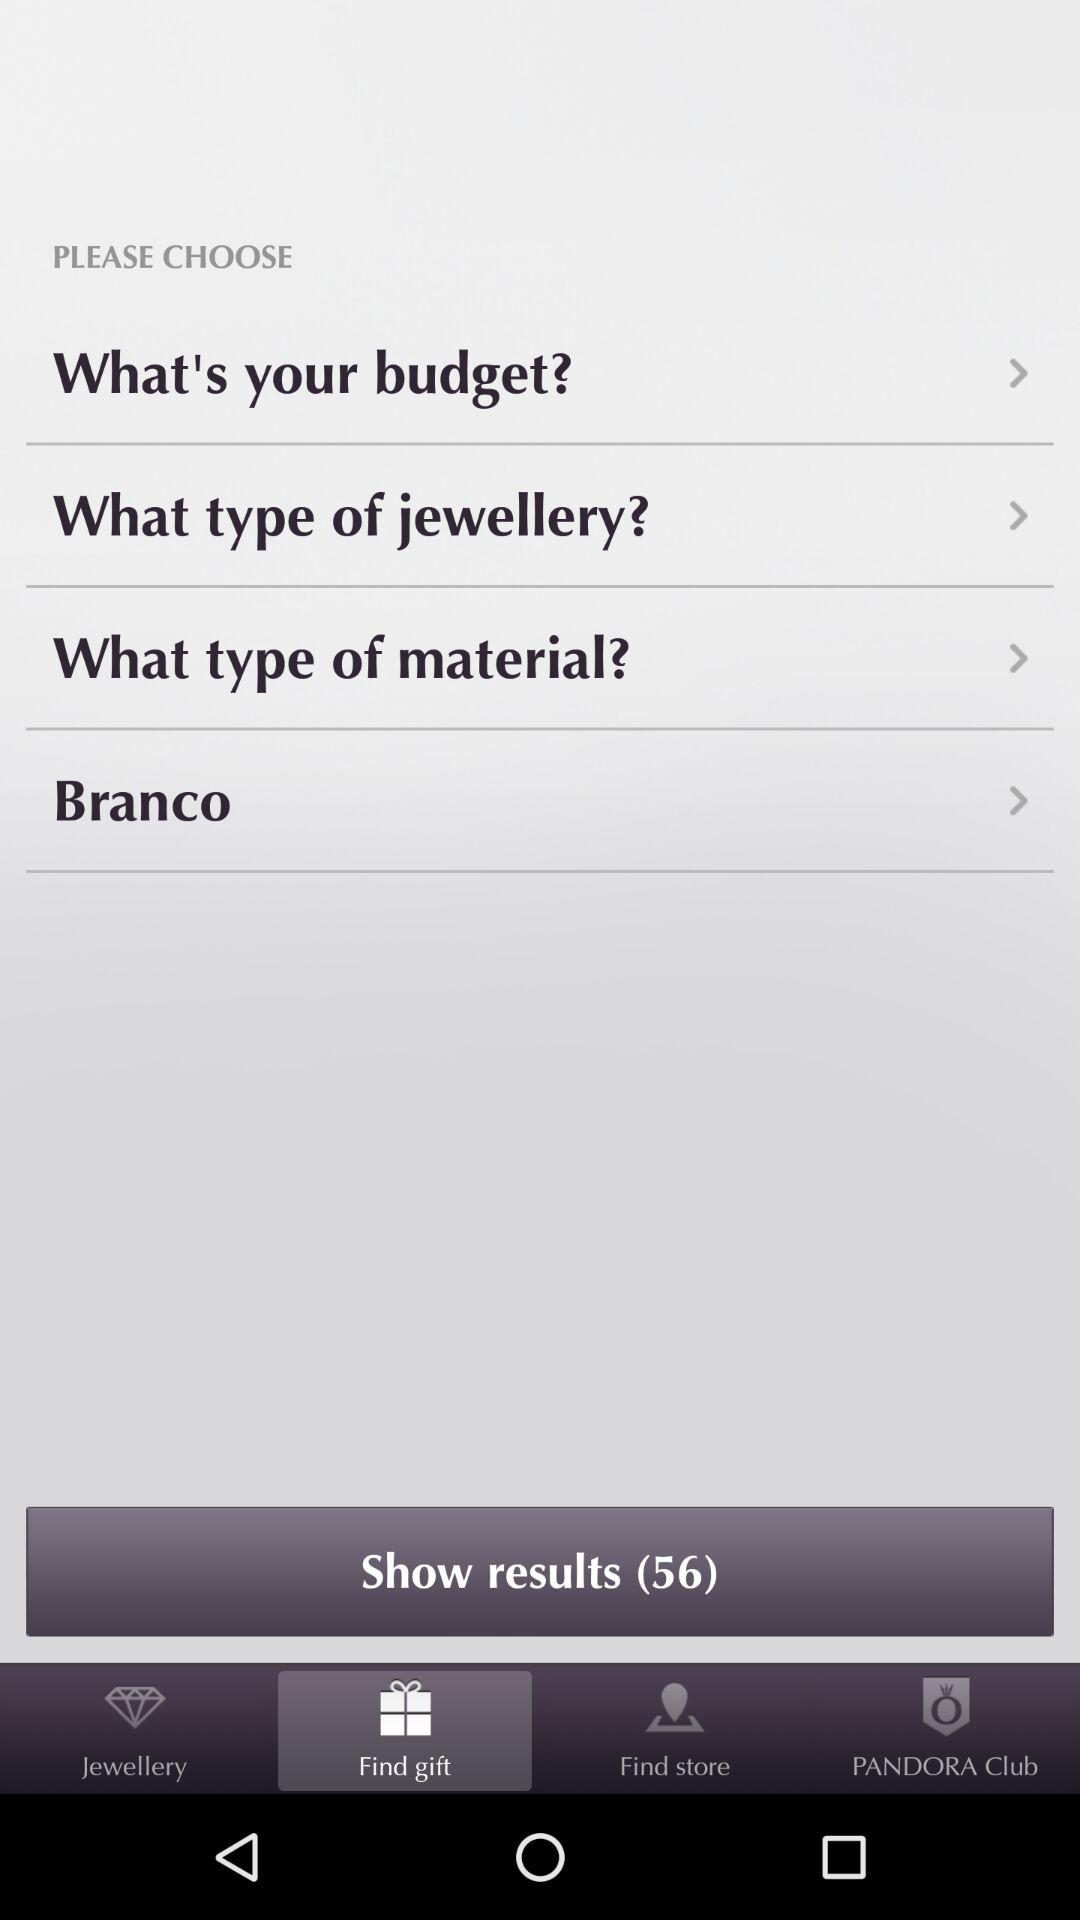How many results in total are there? There are 56 results in total. 